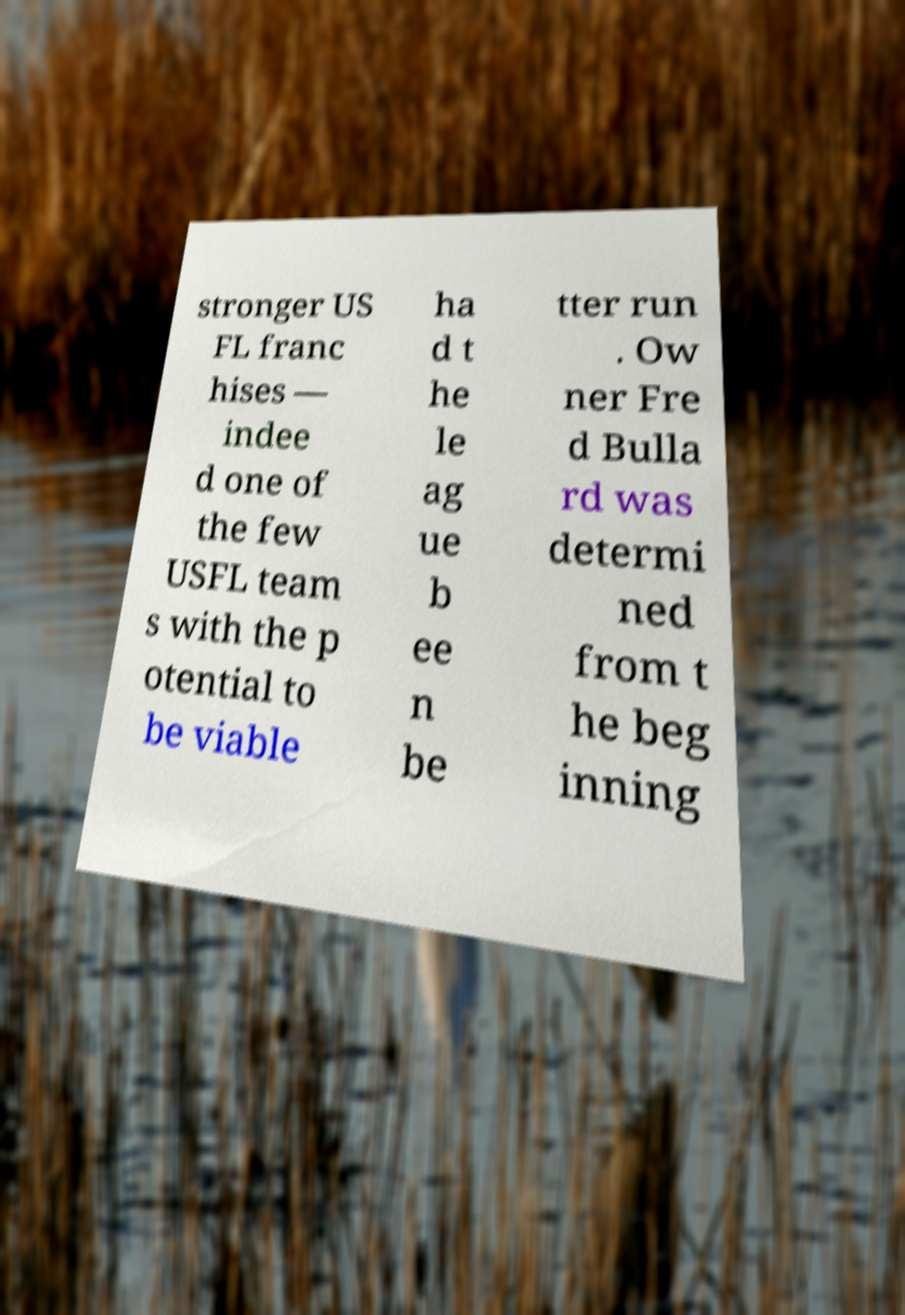Can you accurately transcribe the text from the provided image for me? stronger US FL franc hises — indee d one of the few USFL team s with the p otential to be viable ha d t he le ag ue b ee n be tter run . Ow ner Fre d Bulla rd was determi ned from t he beg inning 